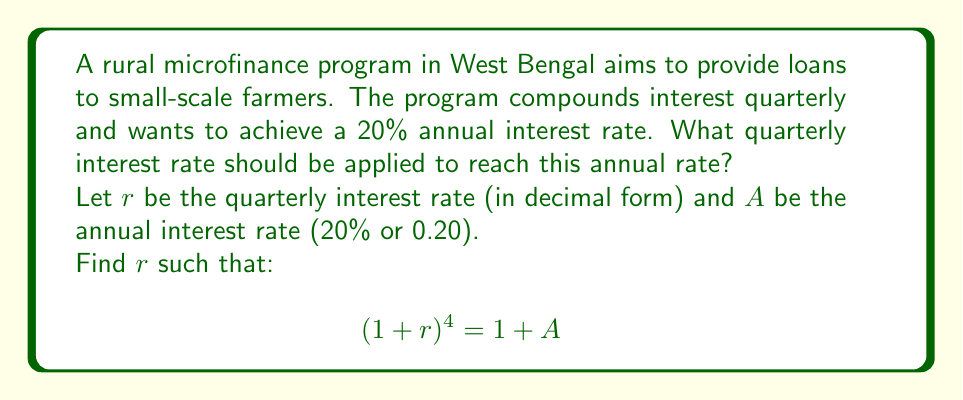Help me with this question. To solve this problem, we'll use the compound interest formula and the concept of effective annual rate:

1) The formula for the effective annual rate with quarterly compounding is:
   $$(1 + r)^4 = 1 + A$$

2) We know that $A = 0.20$ (20% annual rate), so we can substitute this:
   $$(1 + r)^4 = 1 + 0.20 = 1.20$$

3) To solve for $r$, we need to take the fourth root of both sides:
   $$\sqrt[4]{(1 + r)^4} = \sqrt[4]{1.20}$$
   $$1 + r = \sqrt[4]{1.20}$$

4) Subtract 1 from both sides:
   $$r = \sqrt[4]{1.20} - 1$$

5) Calculate the value:
   $$r = 1.0466 - 1 = 0.0466$$

6) Convert to a percentage:
   $$r = 0.0466 \times 100\% = 4.66\%$$

This quarterly rate, when compounded four times a year, will result in a 20% annual interest rate.
Answer: The quarterly interest rate should be 4.66%. 